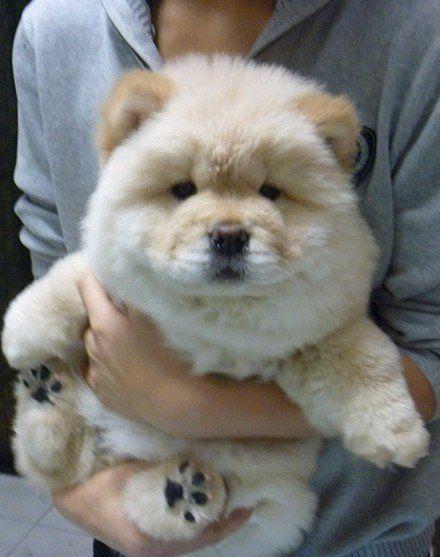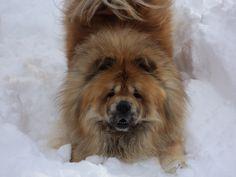The first image is the image on the left, the second image is the image on the right. For the images shown, is this caption "There is a person holding exactly one dog in the image on the left" true? Answer yes or no. Yes. The first image is the image on the left, the second image is the image on the right. Analyze the images presented: Is the assertion "All images show only very young chow pups, and each image shows the same number." valid? Answer yes or no. No. 